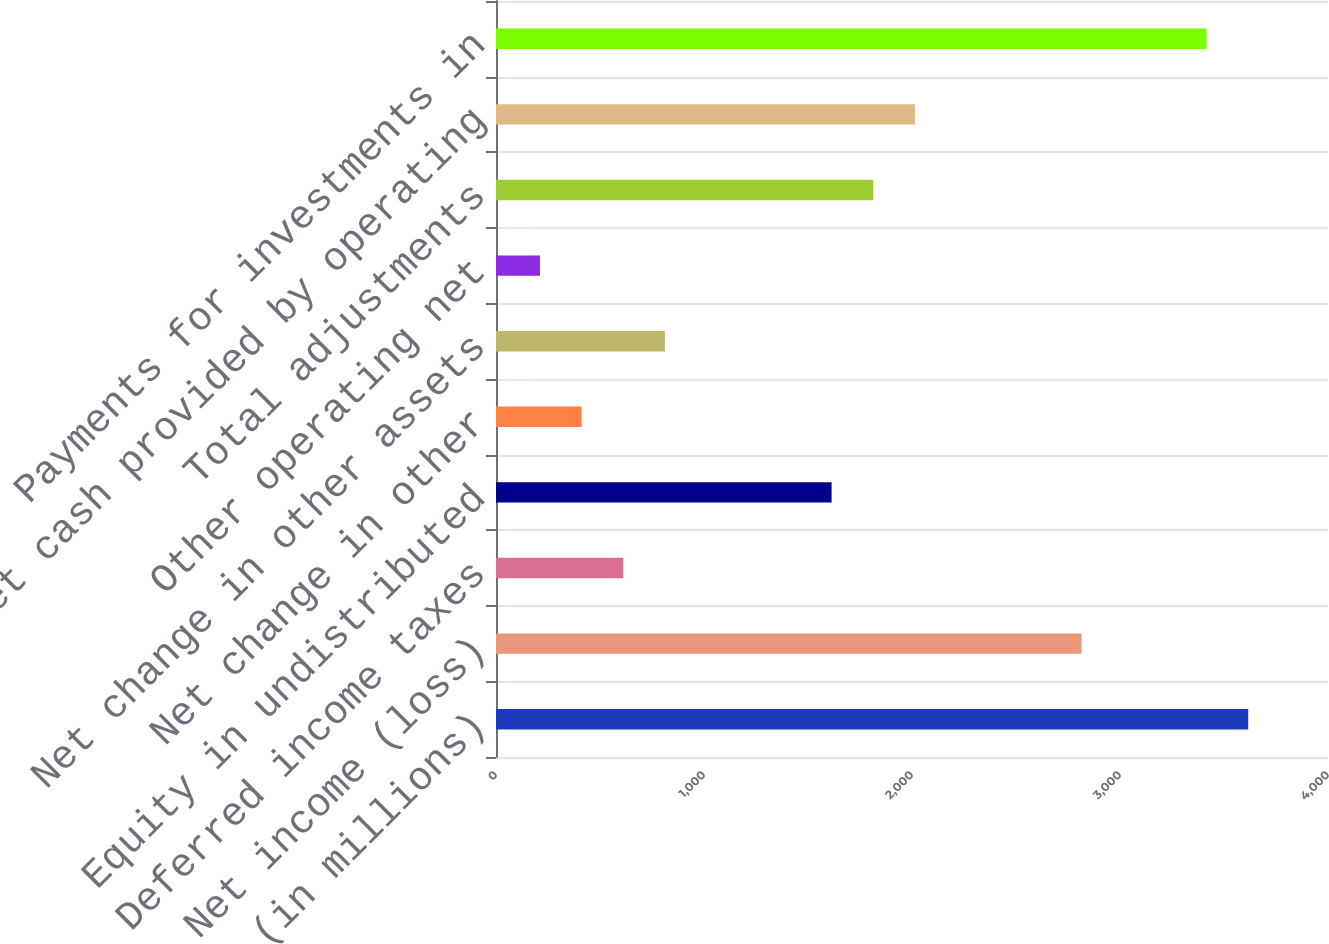Convert chart. <chart><loc_0><loc_0><loc_500><loc_500><bar_chart><fcel>(in millions)<fcel>Net income (loss)<fcel>Deferred income taxes<fcel>Equity in undistributed<fcel>Net change in other<fcel>Net change in other assets<fcel>Other operating net<fcel>Total adjustments<fcel>Net cash provided by operating<fcel>Payments for investments in<nl><fcel>3616.4<fcel>2815.2<fcel>611.9<fcel>1613.4<fcel>411.6<fcel>812.2<fcel>211.3<fcel>1813.7<fcel>2014<fcel>3416.1<nl></chart> 